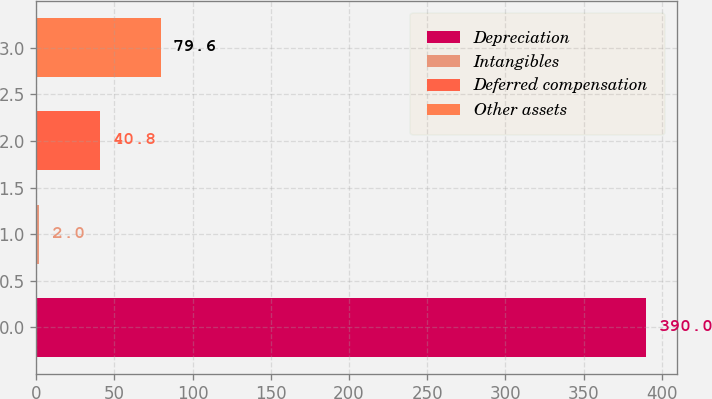<chart> <loc_0><loc_0><loc_500><loc_500><bar_chart><fcel>Depreciation<fcel>Intangibles<fcel>Deferred compensation<fcel>Other assets<nl><fcel>390<fcel>2<fcel>40.8<fcel>79.6<nl></chart> 